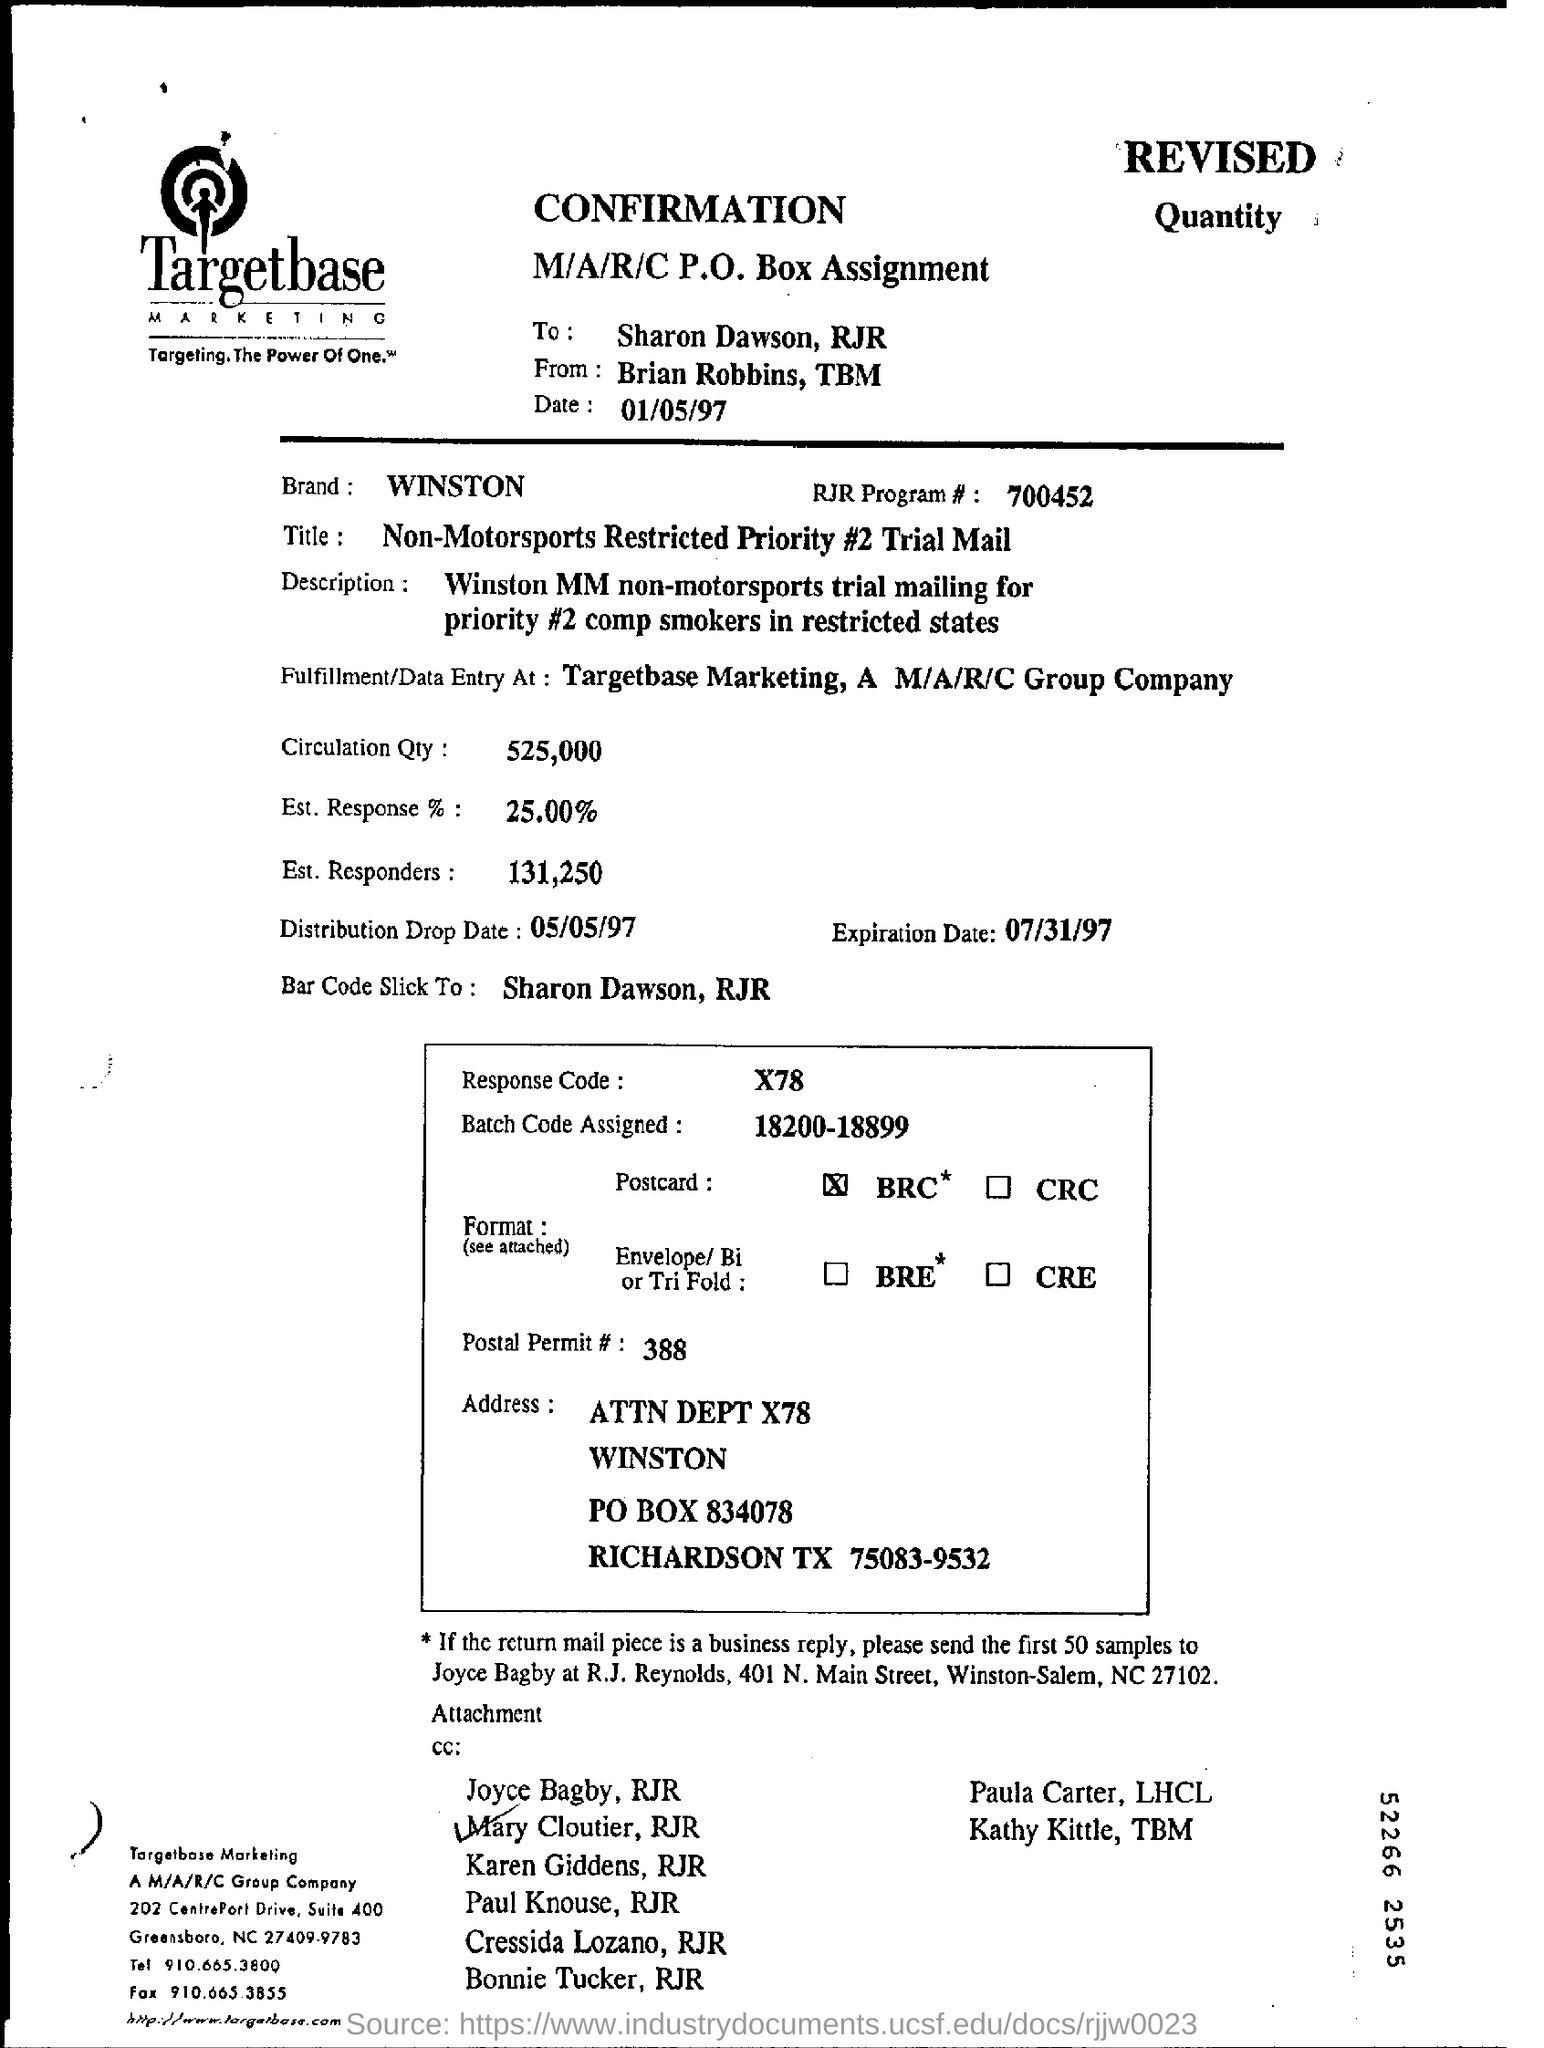Point out several critical features in this image. What is the brand, Winston?" is a question asking for a specific piece of information about a brand called Winston. The response code is X78. According to the given information, an estimated number of responders is 131,250. What has been assigned is a batch code within the range of 18200 to 18899. The date is January 5, 1997. 